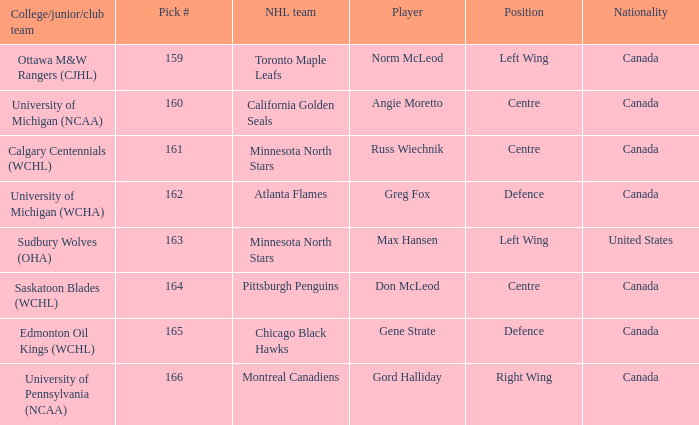What is the nationality of the player from the University of Michigan (NCAA)? Canada. 